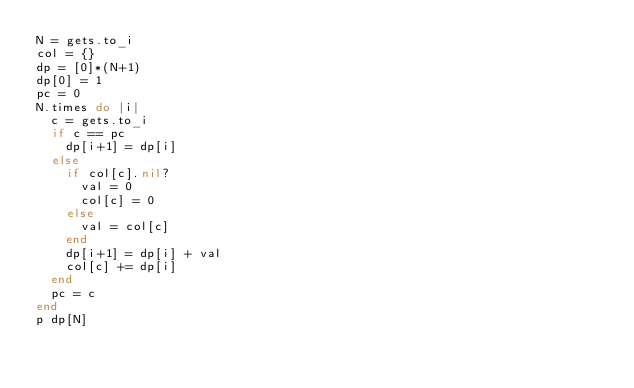<code> <loc_0><loc_0><loc_500><loc_500><_Ruby_>N = gets.to_i
col = {}
dp = [0]*(N+1)
dp[0] = 1
pc = 0
N.times do |i|
  c = gets.to_i
  if c == pc
    dp[i+1] = dp[i]
  else
    if col[c].nil?
      val = 0
      col[c] = 0
    else
      val = col[c]
    end
    dp[i+1] = dp[i] + val
    col[c] += dp[i]
  end
  pc = c
end
p dp[N]</code> 